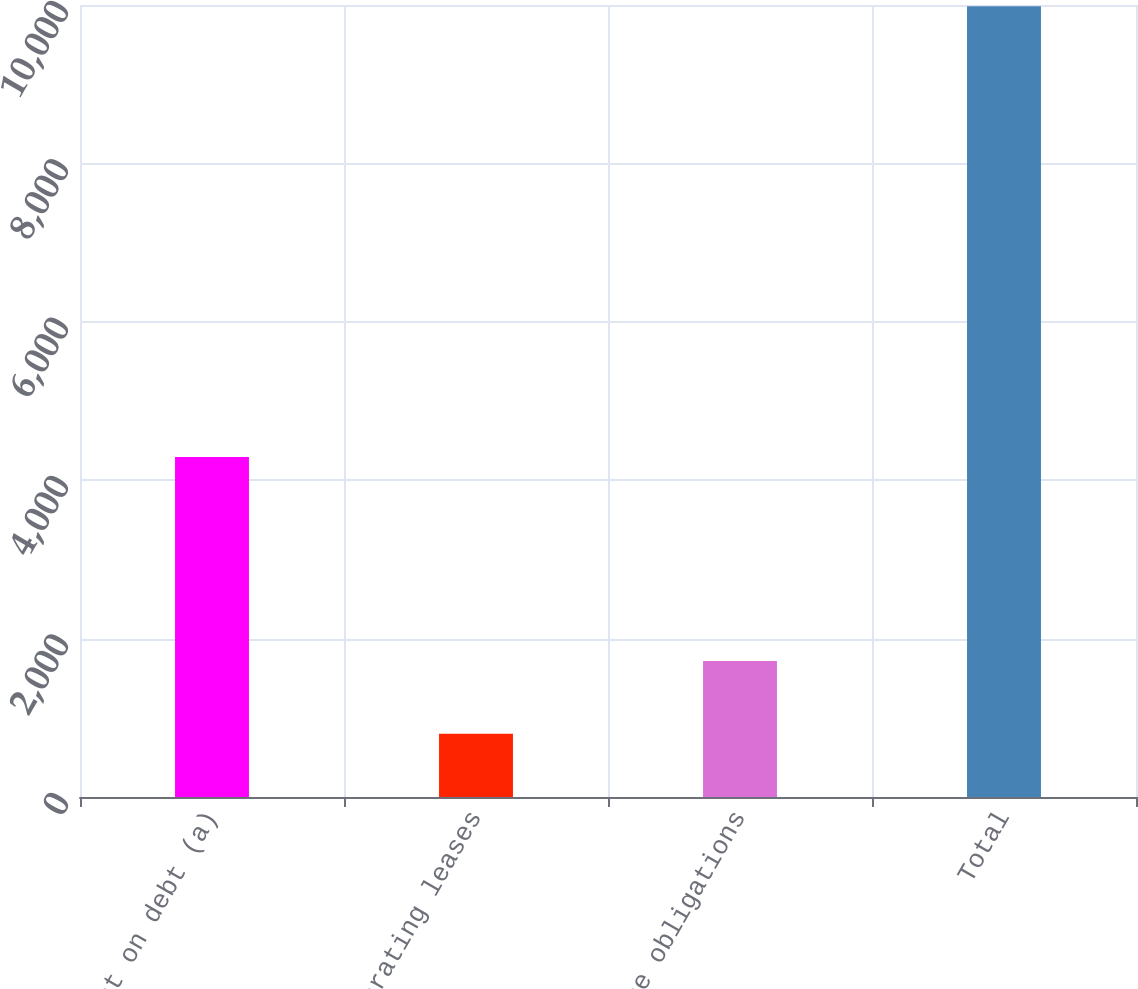<chart> <loc_0><loc_0><loc_500><loc_500><bar_chart><fcel>Interest on debt (a)<fcel>Operating leases<fcel>Purchase obligations<fcel>Total<nl><fcel>4294<fcel>799<fcel>1717.5<fcel>9984<nl></chart> 